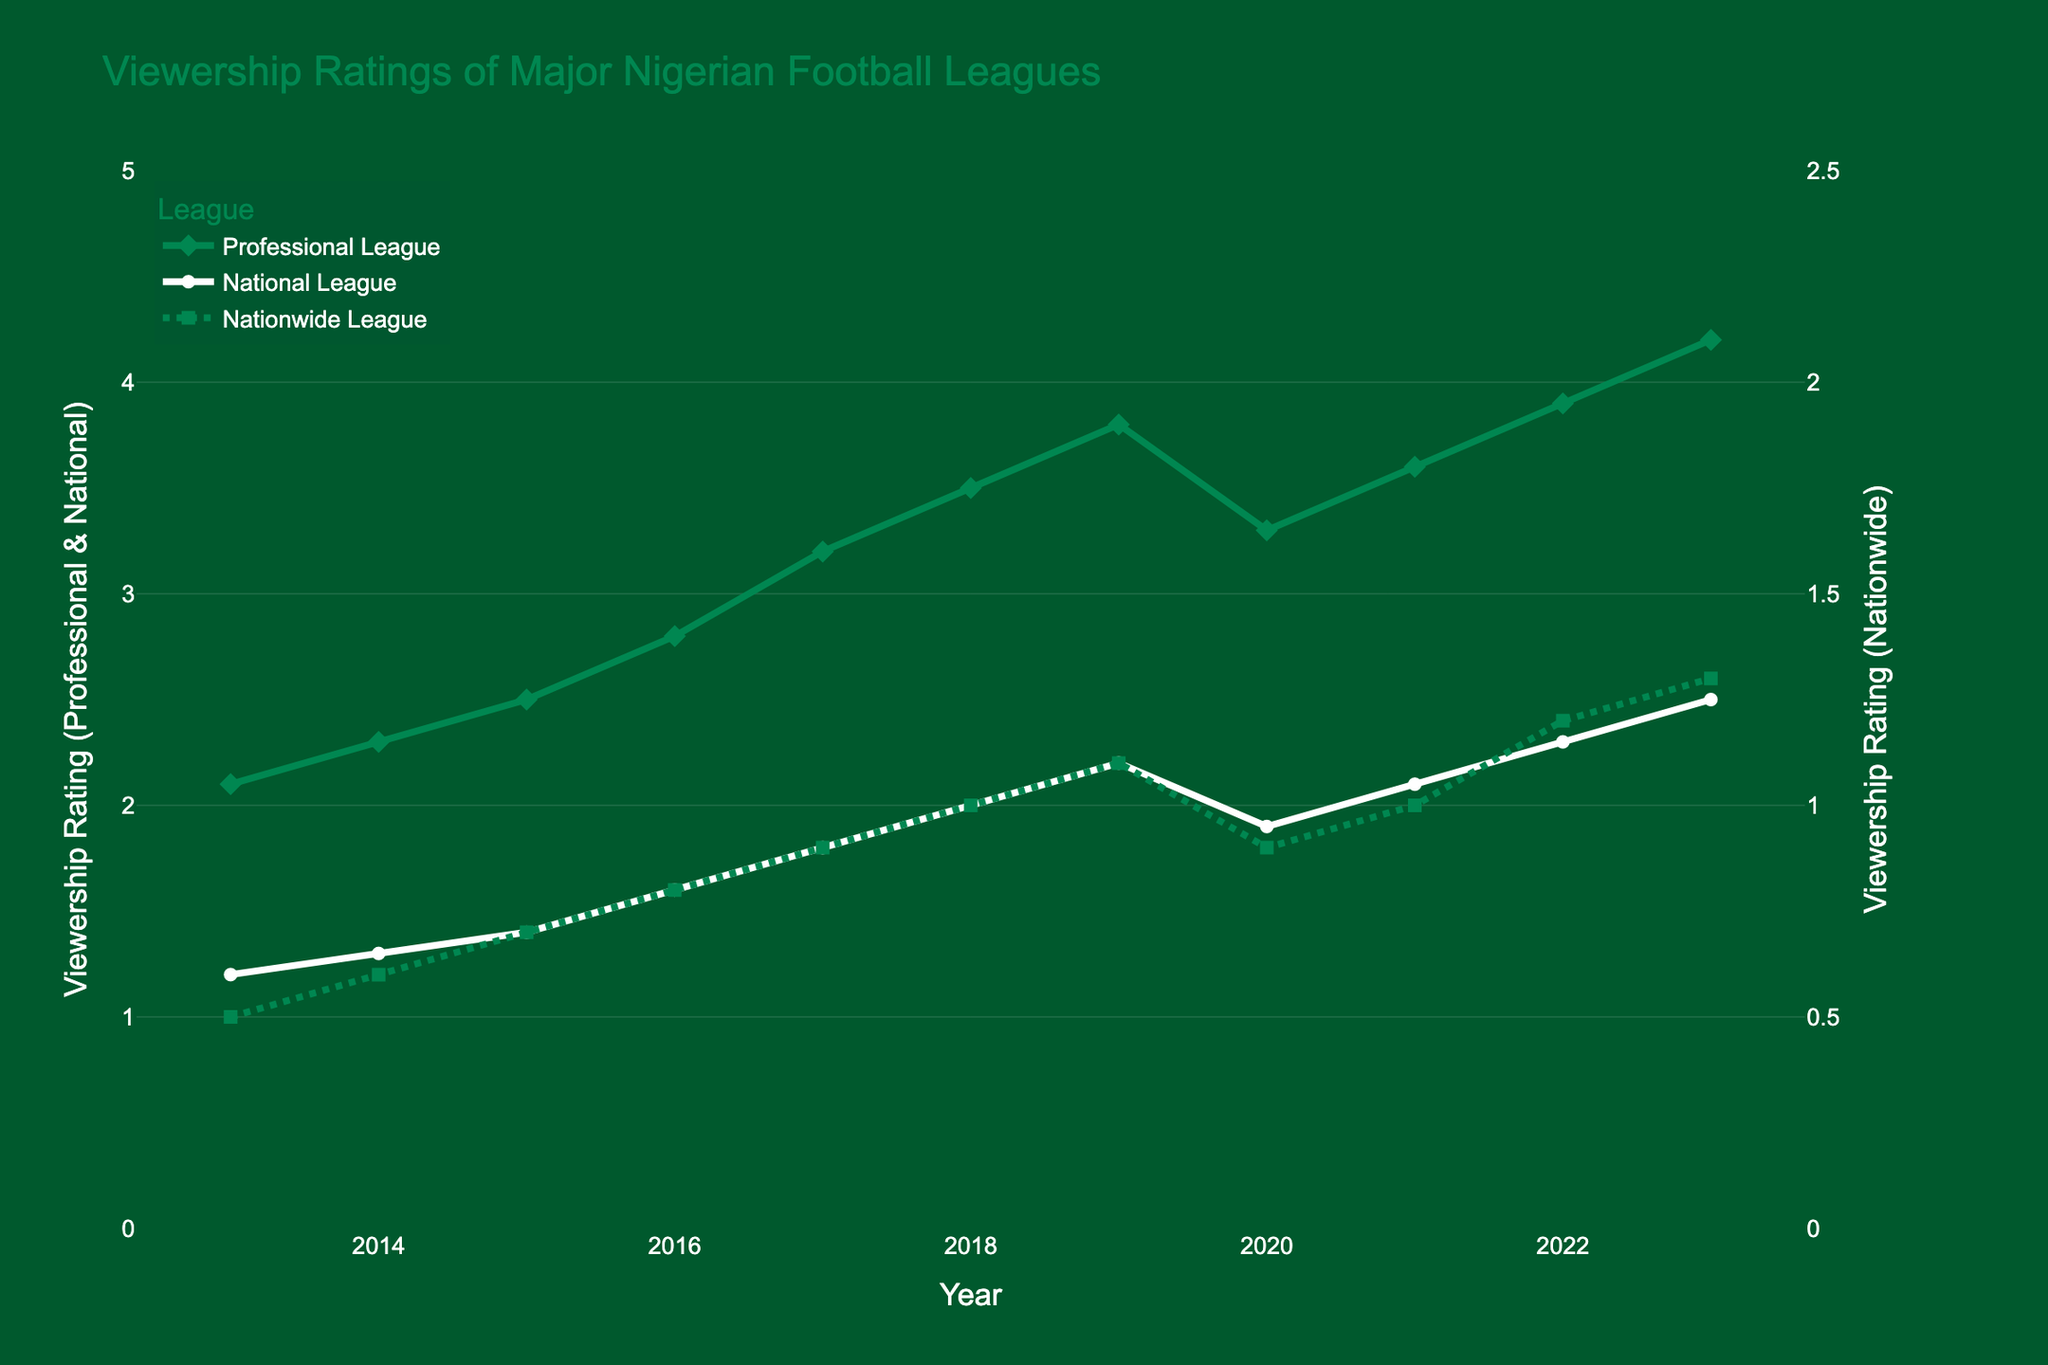What was the viewership rating of the Nigeria Professional Football League in 2020? In 2020, locate the data point for the Nigeria Professional Football League and read off the value from the y-axis corresponding to this point.
Answer: 3.3 Which league had the highest viewership rating in 2023? Locate the viewership ratings for all three leagues in 2023 and compare them. The Nigeria Professional Football League has the highest rating.
Answer: Nigeria Professional Football League What is the sum of the viewership ratings for the Nigeria Professional Football League over the decade? Add the viewership ratings of the Nigeria Professional Football League from 2013 to 2023: 2.1 + 2.3 + 2.5 + 2.8 + 3.2 + 3.5 + 3.8 + 3.3 + 3.6 + 3.9 + 4.2.
Answer: 35.2 How does the viewership trend for the Nigeria National League differ from that of the Nigeria Professional Football League between 2019 and 2020? The Nigeria Professional Football League shows a decrease in viewership from 2019 (3.8) to 2020 (3.3), while the Nigeria National League shows a decrease as well from 2019 (2.2) to 2020 (1.9). Both leagues experienced a decline.
Answer: Both declined In which year did the Nigeria Nationwide League achieve the equivalent rating (1.0) first, and which year did the Nigeria National League reach the same rating? Identify the year for each league when it first hits the equivalent rating of 1.0. Nigeria Nationwide League did this in 2018, and the Nigeria National League did this earlier in 2018.
Answer: 2018, 2018 Compare the viewership rating growth of the Nigeria National League and the Nigeria Nationwide League from 2013 to 2023. Calculate the difference between the viewership ratings in 2023 and 2013 for both leagues. For the Nigeria National League: 2.5 - 1.2 = 1.3. For the Nigeria Nationwide League: 1.3 - 0.5 = 0.8. The Nigeria National League grew more.
Answer: Nigeria National League What visual markers are used to represent the Nationwide League, and what is its color? The Nationwide League is depicted using square markers connected by a dotted line, and its color is green.
Answer: Green squares with dotted line Which leagues experienced a decline in viewership ratings in any consecutive years, and what years did this occur? Identify the periods of decline for each league by comparing consecutive years. The Nigeria Professional Football League declined from 2019 (3.8) to 2020 (3.3), and the Nigeria National League also declined from 2019 (2.2) to 2020 (1.9).
Answer: Professional (2019-2020), National (2019-2020) What is the average viewership rating of the Nigeria Nationwide League for the years observed? Calculate the average by summing the Nationwide League ratings and dividing by the number of years: (0.5 + 0.6 + 0.7 + 0.8 + 0.9 + 1.0 + 1.1 + 0.9 + 1.0 + 1.2 + 1.3) / 11.
Answer: 0.91 